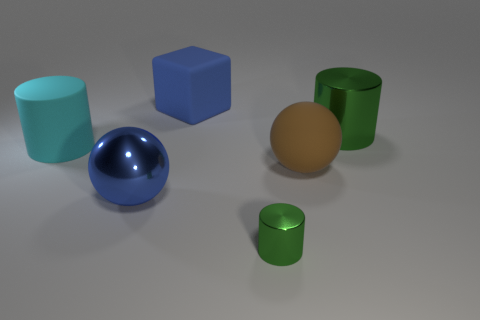What material is the small green cylinder that is to the right of the cylinder to the left of the rubber object that is behind the big cyan object?
Your answer should be very brief. Metal. What is the tiny object made of?
Offer a very short reply. Metal. Do the metal cylinder in front of the large metallic sphere and the ball to the left of the small object have the same color?
Your answer should be very brief. No. Is the number of big cubes greater than the number of big green rubber spheres?
Ensure brevity in your answer.  Yes. What number of large metal cylinders have the same color as the small cylinder?
Offer a terse response. 1. There is a matte thing that is the same shape as the small green metal thing; what color is it?
Make the answer very short. Cyan. The object that is in front of the rubber ball and right of the big blue metallic thing is made of what material?
Offer a very short reply. Metal. Do the big blue thing that is behind the large cyan object and the large cylinder that is right of the blue rubber thing have the same material?
Your answer should be compact. No. What is the size of the blue matte cube?
Keep it short and to the point. Large. There is a brown matte object that is the same shape as the big blue shiny thing; what size is it?
Ensure brevity in your answer.  Large. 